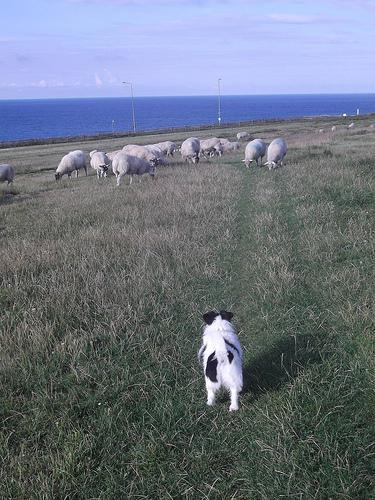Question: what color are the sheep?
Choices:
A. Gray.
B. Black.
C. White.
D. Tan.
Answer with the letter. Answer: C Question: what are the sheep doing?
Choices:
A. Grazing.
B. Eating.
C. Running.
D. Playing.
Answer with the letter. Answer: A 